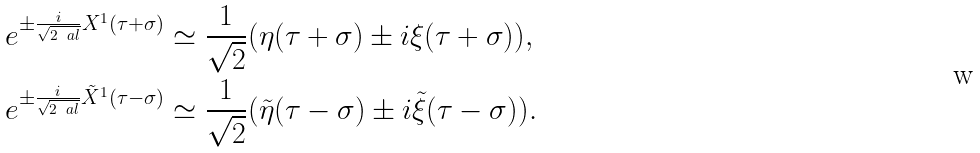<formula> <loc_0><loc_0><loc_500><loc_500>e ^ { \pm \frac { i } { \sqrt { 2 \ a l } } X ^ { 1 } ( \tau + \sigma ) } & \simeq \frac { 1 } { \sqrt { 2 } } ( \eta ( \tau + \sigma ) \pm i \xi ( \tau + \sigma ) ) , \\ e ^ { \pm \frac { i } { \sqrt { 2 \ a l } } \tilde { X } ^ { 1 } ( \tau - \sigma ) } & \simeq \frac { 1 } { \sqrt { 2 } } ( \tilde { \eta } ( \tau - \sigma ) \pm i \tilde { \xi } ( \tau - \sigma ) ) .</formula> 